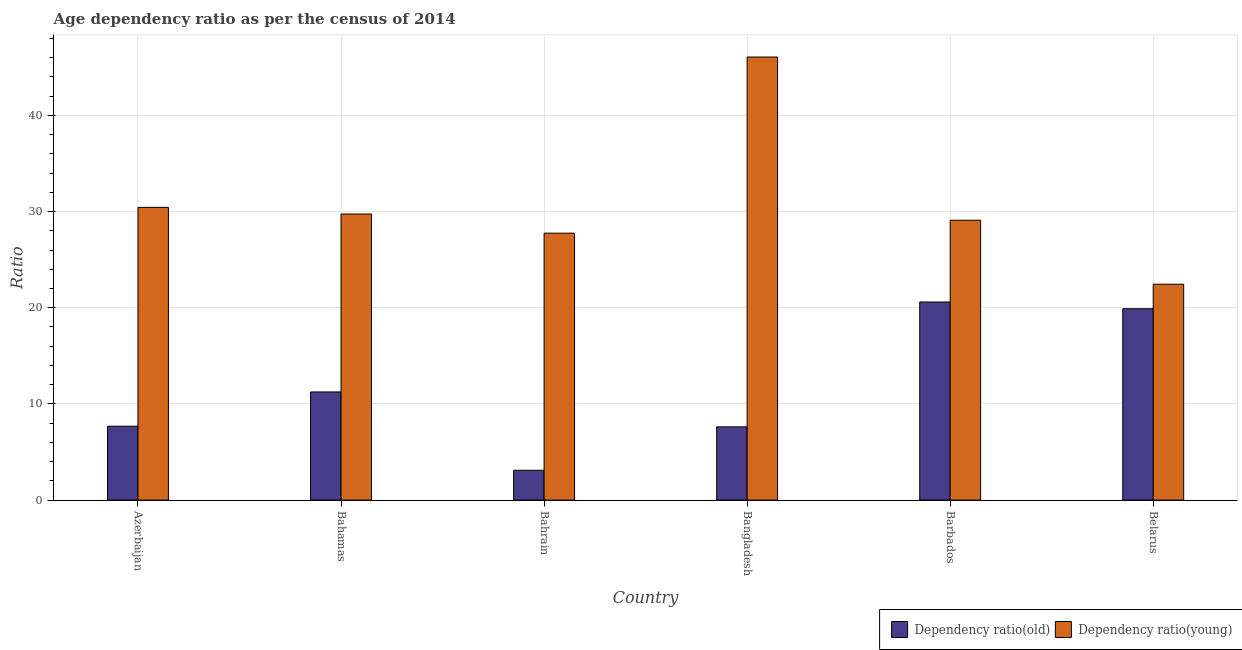How many different coloured bars are there?
Provide a succinct answer. 2. How many groups of bars are there?
Offer a terse response. 6. Are the number of bars per tick equal to the number of legend labels?
Your response must be concise. Yes. What is the label of the 2nd group of bars from the left?
Ensure brevity in your answer.  Bahamas. What is the age dependency ratio(old) in Belarus?
Offer a very short reply. 19.9. Across all countries, what is the maximum age dependency ratio(old)?
Provide a short and direct response. 20.6. Across all countries, what is the minimum age dependency ratio(old)?
Ensure brevity in your answer.  3.1. In which country was the age dependency ratio(young) minimum?
Make the answer very short. Belarus. What is the total age dependency ratio(young) in the graph?
Give a very brief answer. 185.55. What is the difference between the age dependency ratio(young) in Azerbaijan and that in Belarus?
Offer a terse response. 7.99. What is the difference between the age dependency ratio(young) in Bahrain and the age dependency ratio(old) in Belarus?
Ensure brevity in your answer.  7.86. What is the average age dependency ratio(young) per country?
Your answer should be very brief. 30.93. What is the difference between the age dependency ratio(young) and age dependency ratio(old) in Belarus?
Keep it short and to the point. 2.55. What is the ratio of the age dependency ratio(old) in Azerbaijan to that in Barbados?
Your answer should be compact. 0.37. Is the age dependency ratio(old) in Bangladesh less than that in Barbados?
Provide a short and direct response. Yes. Is the difference between the age dependency ratio(old) in Bahamas and Barbados greater than the difference between the age dependency ratio(young) in Bahamas and Barbados?
Provide a short and direct response. No. What is the difference between the highest and the second highest age dependency ratio(young)?
Your answer should be very brief. 15.63. What is the difference between the highest and the lowest age dependency ratio(young)?
Offer a terse response. 23.62. In how many countries, is the age dependency ratio(young) greater than the average age dependency ratio(young) taken over all countries?
Offer a terse response. 1. What does the 2nd bar from the left in Bangladesh represents?
Your answer should be compact. Dependency ratio(young). What does the 2nd bar from the right in Bahamas represents?
Provide a short and direct response. Dependency ratio(old). Are all the bars in the graph horizontal?
Your response must be concise. No. How many countries are there in the graph?
Your answer should be compact. 6. What is the difference between two consecutive major ticks on the Y-axis?
Give a very brief answer. 10. Are the values on the major ticks of Y-axis written in scientific E-notation?
Your answer should be very brief. No. Does the graph contain any zero values?
Keep it short and to the point. No. Does the graph contain grids?
Provide a succinct answer. Yes. How many legend labels are there?
Provide a short and direct response. 2. How are the legend labels stacked?
Your response must be concise. Horizontal. What is the title of the graph?
Keep it short and to the point. Age dependency ratio as per the census of 2014. What is the label or title of the Y-axis?
Keep it short and to the point. Ratio. What is the Ratio in Dependency ratio(old) in Azerbaijan?
Make the answer very short. 7.68. What is the Ratio of Dependency ratio(young) in Azerbaijan?
Provide a succinct answer. 30.44. What is the Ratio of Dependency ratio(old) in Bahamas?
Give a very brief answer. 11.25. What is the Ratio in Dependency ratio(young) in Bahamas?
Your answer should be compact. 29.75. What is the Ratio of Dependency ratio(old) in Bahrain?
Your answer should be very brief. 3.1. What is the Ratio of Dependency ratio(young) in Bahrain?
Make the answer very short. 27.76. What is the Ratio of Dependency ratio(old) in Bangladesh?
Provide a short and direct response. 7.62. What is the Ratio of Dependency ratio(young) in Bangladesh?
Offer a very short reply. 46.07. What is the Ratio of Dependency ratio(old) in Barbados?
Your response must be concise. 20.6. What is the Ratio of Dependency ratio(young) in Barbados?
Keep it short and to the point. 29.1. What is the Ratio of Dependency ratio(old) in Belarus?
Keep it short and to the point. 19.9. What is the Ratio of Dependency ratio(young) in Belarus?
Offer a terse response. 22.45. Across all countries, what is the maximum Ratio of Dependency ratio(old)?
Your answer should be very brief. 20.6. Across all countries, what is the maximum Ratio in Dependency ratio(young)?
Offer a terse response. 46.07. Across all countries, what is the minimum Ratio of Dependency ratio(old)?
Provide a short and direct response. 3.1. Across all countries, what is the minimum Ratio in Dependency ratio(young)?
Ensure brevity in your answer.  22.45. What is the total Ratio in Dependency ratio(old) in the graph?
Provide a short and direct response. 70.14. What is the total Ratio in Dependency ratio(young) in the graph?
Your response must be concise. 185.55. What is the difference between the Ratio of Dependency ratio(old) in Azerbaijan and that in Bahamas?
Keep it short and to the point. -3.56. What is the difference between the Ratio in Dependency ratio(young) in Azerbaijan and that in Bahamas?
Make the answer very short. 0.69. What is the difference between the Ratio of Dependency ratio(old) in Azerbaijan and that in Bahrain?
Your answer should be compact. 4.58. What is the difference between the Ratio of Dependency ratio(young) in Azerbaijan and that in Bahrain?
Keep it short and to the point. 2.68. What is the difference between the Ratio in Dependency ratio(old) in Azerbaijan and that in Bangladesh?
Provide a short and direct response. 0.07. What is the difference between the Ratio of Dependency ratio(young) in Azerbaijan and that in Bangladesh?
Keep it short and to the point. -15.63. What is the difference between the Ratio of Dependency ratio(old) in Azerbaijan and that in Barbados?
Ensure brevity in your answer.  -12.91. What is the difference between the Ratio of Dependency ratio(young) in Azerbaijan and that in Barbados?
Make the answer very short. 1.34. What is the difference between the Ratio in Dependency ratio(old) in Azerbaijan and that in Belarus?
Make the answer very short. -12.22. What is the difference between the Ratio of Dependency ratio(young) in Azerbaijan and that in Belarus?
Keep it short and to the point. 7.99. What is the difference between the Ratio in Dependency ratio(old) in Bahamas and that in Bahrain?
Give a very brief answer. 8.14. What is the difference between the Ratio of Dependency ratio(young) in Bahamas and that in Bahrain?
Offer a terse response. 1.99. What is the difference between the Ratio of Dependency ratio(old) in Bahamas and that in Bangladesh?
Provide a short and direct response. 3.63. What is the difference between the Ratio in Dependency ratio(young) in Bahamas and that in Bangladesh?
Your answer should be very brief. -16.32. What is the difference between the Ratio in Dependency ratio(old) in Bahamas and that in Barbados?
Ensure brevity in your answer.  -9.35. What is the difference between the Ratio of Dependency ratio(young) in Bahamas and that in Barbados?
Offer a very short reply. 0.65. What is the difference between the Ratio in Dependency ratio(old) in Bahamas and that in Belarus?
Your answer should be compact. -8.65. What is the difference between the Ratio in Dependency ratio(young) in Bahamas and that in Belarus?
Your answer should be compact. 7.3. What is the difference between the Ratio in Dependency ratio(old) in Bahrain and that in Bangladesh?
Your answer should be very brief. -4.51. What is the difference between the Ratio of Dependency ratio(young) in Bahrain and that in Bangladesh?
Ensure brevity in your answer.  -18.31. What is the difference between the Ratio of Dependency ratio(old) in Bahrain and that in Barbados?
Provide a succinct answer. -17.49. What is the difference between the Ratio of Dependency ratio(young) in Bahrain and that in Barbados?
Offer a terse response. -1.34. What is the difference between the Ratio of Dependency ratio(old) in Bahrain and that in Belarus?
Ensure brevity in your answer.  -16.8. What is the difference between the Ratio in Dependency ratio(young) in Bahrain and that in Belarus?
Offer a very short reply. 5.31. What is the difference between the Ratio of Dependency ratio(old) in Bangladesh and that in Barbados?
Ensure brevity in your answer.  -12.98. What is the difference between the Ratio of Dependency ratio(young) in Bangladesh and that in Barbados?
Your answer should be compact. 16.97. What is the difference between the Ratio of Dependency ratio(old) in Bangladesh and that in Belarus?
Make the answer very short. -12.28. What is the difference between the Ratio in Dependency ratio(young) in Bangladesh and that in Belarus?
Ensure brevity in your answer.  23.62. What is the difference between the Ratio in Dependency ratio(old) in Barbados and that in Belarus?
Offer a terse response. 0.7. What is the difference between the Ratio in Dependency ratio(young) in Barbados and that in Belarus?
Provide a short and direct response. 6.65. What is the difference between the Ratio in Dependency ratio(old) in Azerbaijan and the Ratio in Dependency ratio(young) in Bahamas?
Provide a short and direct response. -22.07. What is the difference between the Ratio in Dependency ratio(old) in Azerbaijan and the Ratio in Dependency ratio(young) in Bahrain?
Provide a succinct answer. -20.07. What is the difference between the Ratio of Dependency ratio(old) in Azerbaijan and the Ratio of Dependency ratio(young) in Bangladesh?
Offer a very short reply. -38.39. What is the difference between the Ratio of Dependency ratio(old) in Azerbaijan and the Ratio of Dependency ratio(young) in Barbados?
Keep it short and to the point. -21.42. What is the difference between the Ratio in Dependency ratio(old) in Azerbaijan and the Ratio in Dependency ratio(young) in Belarus?
Offer a very short reply. -14.76. What is the difference between the Ratio of Dependency ratio(old) in Bahamas and the Ratio of Dependency ratio(young) in Bahrain?
Provide a short and direct response. -16.51. What is the difference between the Ratio in Dependency ratio(old) in Bahamas and the Ratio in Dependency ratio(young) in Bangladesh?
Offer a very short reply. -34.82. What is the difference between the Ratio of Dependency ratio(old) in Bahamas and the Ratio of Dependency ratio(young) in Barbados?
Provide a succinct answer. -17.85. What is the difference between the Ratio of Dependency ratio(old) in Bahamas and the Ratio of Dependency ratio(young) in Belarus?
Make the answer very short. -11.2. What is the difference between the Ratio in Dependency ratio(old) in Bahrain and the Ratio in Dependency ratio(young) in Bangladesh?
Make the answer very short. -42.97. What is the difference between the Ratio of Dependency ratio(old) in Bahrain and the Ratio of Dependency ratio(young) in Barbados?
Make the answer very short. -26. What is the difference between the Ratio of Dependency ratio(old) in Bahrain and the Ratio of Dependency ratio(young) in Belarus?
Provide a short and direct response. -19.34. What is the difference between the Ratio of Dependency ratio(old) in Bangladesh and the Ratio of Dependency ratio(young) in Barbados?
Keep it short and to the point. -21.48. What is the difference between the Ratio of Dependency ratio(old) in Bangladesh and the Ratio of Dependency ratio(young) in Belarus?
Your answer should be compact. -14.83. What is the difference between the Ratio of Dependency ratio(old) in Barbados and the Ratio of Dependency ratio(young) in Belarus?
Give a very brief answer. -1.85. What is the average Ratio in Dependency ratio(old) per country?
Provide a short and direct response. 11.69. What is the average Ratio in Dependency ratio(young) per country?
Provide a succinct answer. 30.93. What is the difference between the Ratio in Dependency ratio(old) and Ratio in Dependency ratio(young) in Azerbaijan?
Provide a succinct answer. -22.75. What is the difference between the Ratio in Dependency ratio(old) and Ratio in Dependency ratio(young) in Bahamas?
Provide a succinct answer. -18.5. What is the difference between the Ratio of Dependency ratio(old) and Ratio of Dependency ratio(young) in Bahrain?
Offer a terse response. -24.65. What is the difference between the Ratio of Dependency ratio(old) and Ratio of Dependency ratio(young) in Bangladesh?
Your answer should be compact. -38.45. What is the difference between the Ratio in Dependency ratio(old) and Ratio in Dependency ratio(young) in Barbados?
Offer a terse response. -8.5. What is the difference between the Ratio in Dependency ratio(old) and Ratio in Dependency ratio(young) in Belarus?
Give a very brief answer. -2.55. What is the ratio of the Ratio in Dependency ratio(old) in Azerbaijan to that in Bahamas?
Keep it short and to the point. 0.68. What is the ratio of the Ratio of Dependency ratio(young) in Azerbaijan to that in Bahamas?
Offer a very short reply. 1.02. What is the ratio of the Ratio of Dependency ratio(old) in Azerbaijan to that in Bahrain?
Offer a very short reply. 2.48. What is the ratio of the Ratio in Dependency ratio(young) in Azerbaijan to that in Bahrain?
Offer a terse response. 1.1. What is the ratio of the Ratio in Dependency ratio(old) in Azerbaijan to that in Bangladesh?
Your answer should be compact. 1.01. What is the ratio of the Ratio in Dependency ratio(young) in Azerbaijan to that in Bangladesh?
Make the answer very short. 0.66. What is the ratio of the Ratio of Dependency ratio(old) in Azerbaijan to that in Barbados?
Offer a very short reply. 0.37. What is the ratio of the Ratio of Dependency ratio(young) in Azerbaijan to that in Barbados?
Give a very brief answer. 1.05. What is the ratio of the Ratio of Dependency ratio(old) in Azerbaijan to that in Belarus?
Give a very brief answer. 0.39. What is the ratio of the Ratio in Dependency ratio(young) in Azerbaijan to that in Belarus?
Your response must be concise. 1.36. What is the ratio of the Ratio of Dependency ratio(old) in Bahamas to that in Bahrain?
Offer a very short reply. 3.63. What is the ratio of the Ratio of Dependency ratio(young) in Bahamas to that in Bahrain?
Make the answer very short. 1.07. What is the ratio of the Ratio of Dependency ratio(old) in Bahamas to that in Bangladesh?
Offer a terse response. 1.48. What is the ratio of the Ratio in Dependency ratio(young) in Bahamas to that in Bangladesh?
Ensure brevity in your answer.  0.65. What is the ratio of the Ratio of Dependency ratio(old) in Bahamas to that in Barbados?
Offer a very short reply. 0.55. What is the ratio of the Ratio in Dependency ratio(young) in Bahamas to that in Barbados?
Your response must be concise. 1.02. What is the ratio of the Ratio of Dependency ratio(old) in Bahamas to that in Belarus?
Keep it short and to the point. 0.57. What is the ratio of the Ratio of Dependency ratio(young) in Bahamas to that in Belarus?
Provide a short and direct response. 1.33. What is the ratio of the Ratio of Dependency ratio(old) in Bahrain to that in Bangladesh?
Your answer should be compact. 0.41. What is the ratio of the Ratio in Dependency ratio(young) in Bahrain to that in Bangladesh?
Offer a very short reply. 0.6. What is the ratio of the Ratio in Dependency ratio(old) in Bahrain to that in Barbados?
Offer a very short reply. 0.15. What is the ratio of the Ratio of Dependency ratio(young) in Bahrain to that in Barbados?
Your response must be concise. 0.95. What is the ratio of the Ratio in Dependency ratio(old) in Bahrain to that in Belarus?
Give a very brief answer. 0.16. What is the ratio of the Ratio of Dependency ratio(young) in Bahrain to that in Belarus?
Your response must be concise. 1.24. What is the ratio of the Ratio in Dependency ratio(old) in Bangladesh to that in Barbados?
Make the answer very short. 0.37. What is the ratio of the Ratio of Dependency ratio(young) in Bangladesh to that in Barbados?
Give a very brief answer. 1.58. What is the ratio of the Ratio in Dependency ratio(old) in Bangladesh to that in Belarus?
Your response must be concise. 0.38. What is the ratio of the Ratio in Dependency ratio(young) in Bangladesh to that in Belarus?
Your answer should be compact. 2.05. What is the ratio of the Ratio of Dependency ratio(old) in Barbados to that in Belarus?
Keep it short and to the point. 1.04. What is the ratio of the Ratio in Dependency ratio(young) in Barbados to that in Belarus?
Keep it short and to the point. 1.3. What is the difference between the highest and the second highest Ratio in Dependency ratio(old)?
Your answer should be very brief. 0.7. What is the difference between the highest and the second highest Ratio in Dependency ratio(young)?
Offer a very short reply. 15.63. What is the difference between the highest and the lowest Ratio in Dependency ratio(old)?
Your answer should be compact. 17.49. What is the difference between the highest and the lowest Ratio in Dependency ratio(young)?
Make the answer very short. 23.62. 